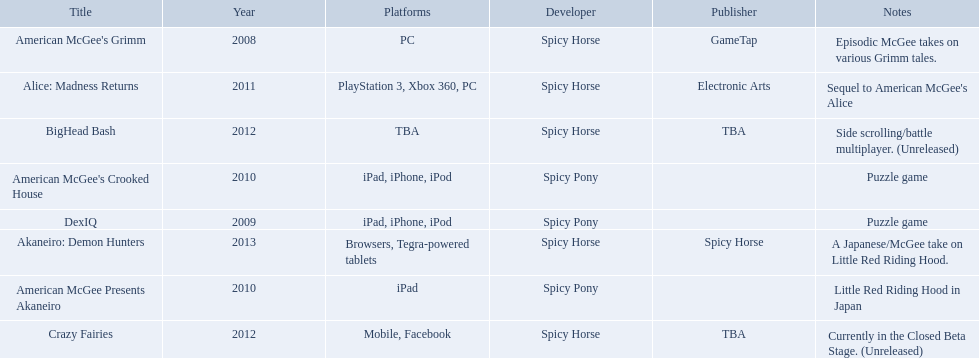What are all of the titles? American McGee's Grimm, DexIQ, American McGee Presents Akaneiro, American McGee's Crooked House, Alice: Madness Returns, BigHead Bash, Crazy Fairies, Akaneiro: Demon Hunters. Who published each title? GameTap, , , , Electronic Arts, TBA, TBA, Spicy Horse. Which game was published by electronics arts? Alice: Madness Returns. 